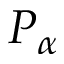<formula> <loc_0><loc_0><loc_500><loc_500>P _ { \alpha }</formula> 